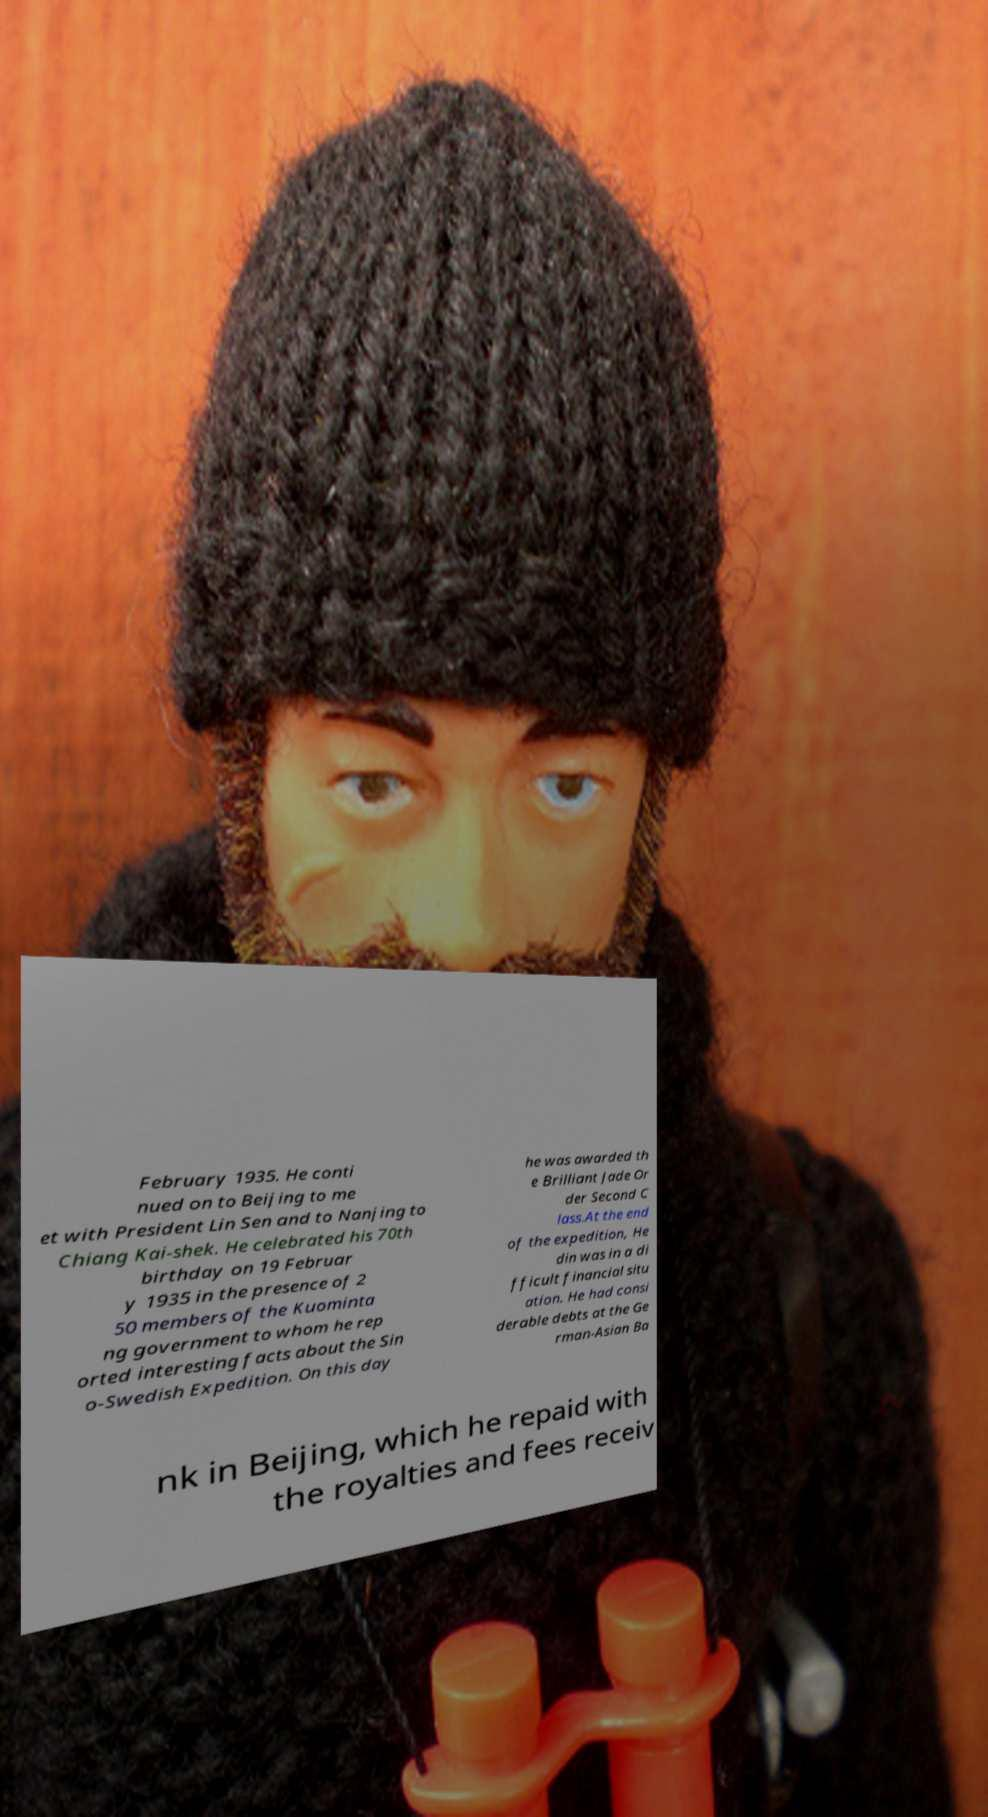For documentation purposes, I need the text within this image transcribed. Could you provide that? February 1935. He conti nued on to Beijing to me et with President Lin Sen and to Nanjing to Chiang Kai-shek. He celebrated his 70th birthday on 19 Februar y 1935 in the presence of 2 50 members of the Kuominta ng government to whom he rep orted interesting facts about the Sin o-Swedish Expedition. On this day he was awarded th e Brilliant Jade Or der Second C lass.At the end of the expedition, He din was in a di fficult financial situ ation. He had consi derable debts at the Ge rman-Asian Ba nk in Beijing, which he repaid with the royalties and fees receiv 